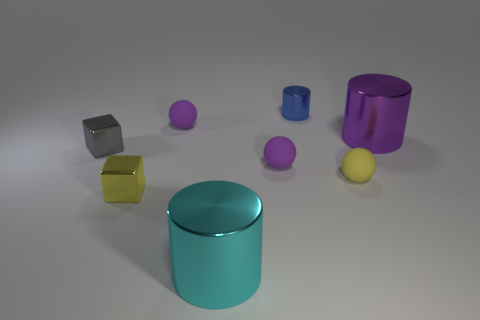Can you describe the arrangement of the colored objects? Certainly! The image displays a collection of cylindrical and cubic objects with a glossy finish, arranged seemingly haphazardly on a flat surface. There's a yellow cubic block quite prominent at the centre. A blue cylinder lies towards the left, and there is a purple cylinder at a slight distance. There are also two small purplish spheres and a smaller blue cylinder, all placed without any strict order. Additionally, a steel-colored cube and a golden-yellow translucent cube are present. 